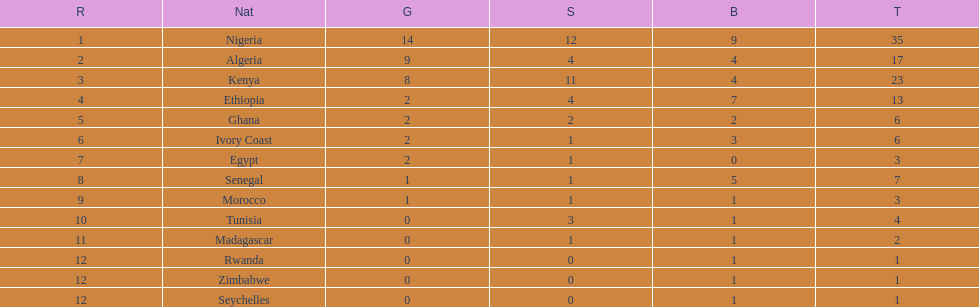The nation above algeria Nigeria. 